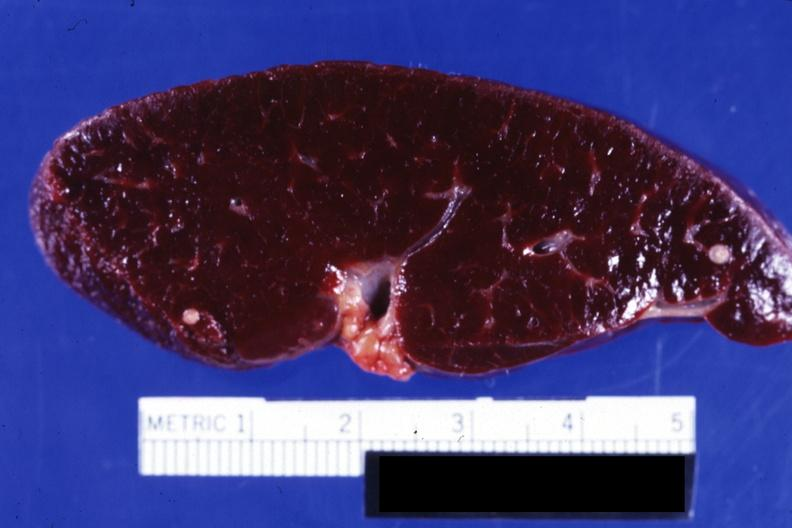s adrenal of premature 30 week gestation gram infant lesion present?
Answer the question using a single word or phrase. No 